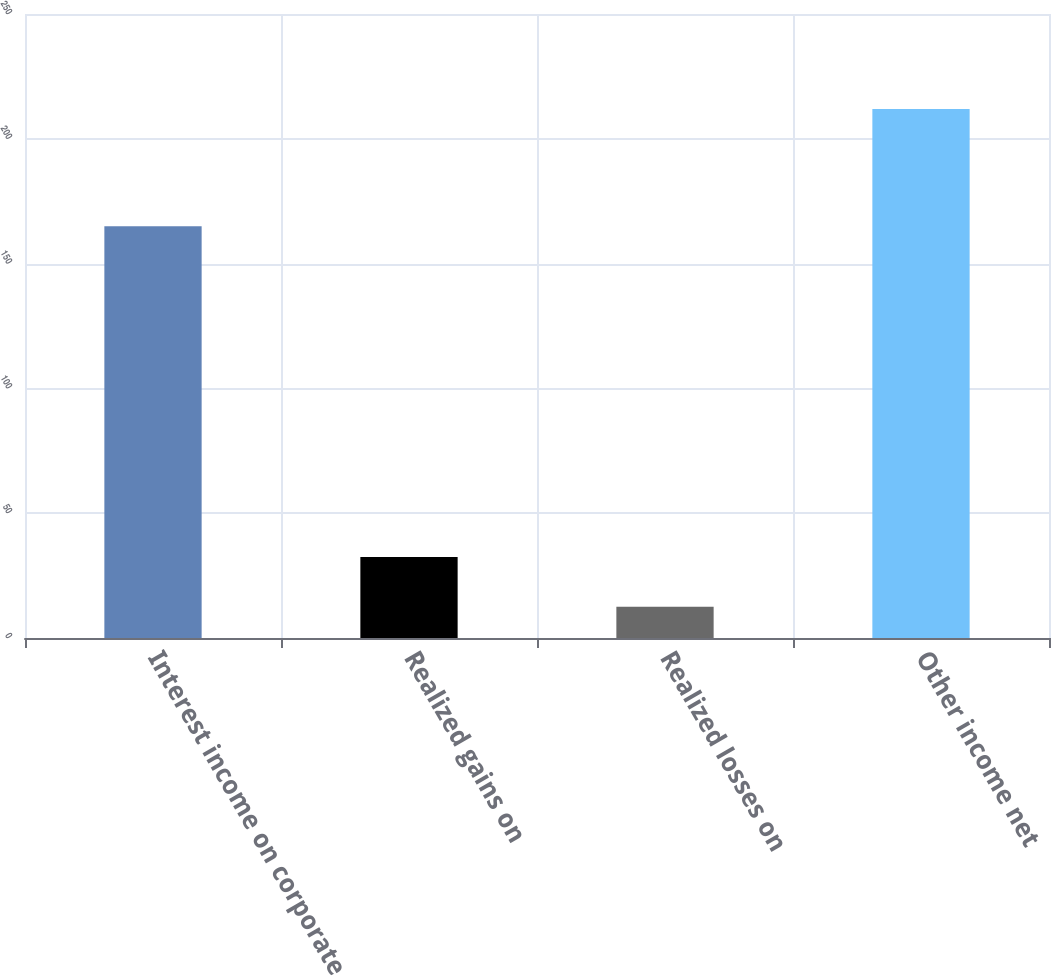<chart> <loc_0><loc_0><loc_500><loc_500><bar_chart><fcel>Interest income on corporate<fcel>Realized gains on<fcel>Realized losses on<fcel>Other income net<nl><fcel>165<fcel>32.44<fcel>12.5<fcel>211.9<nl></chart> 